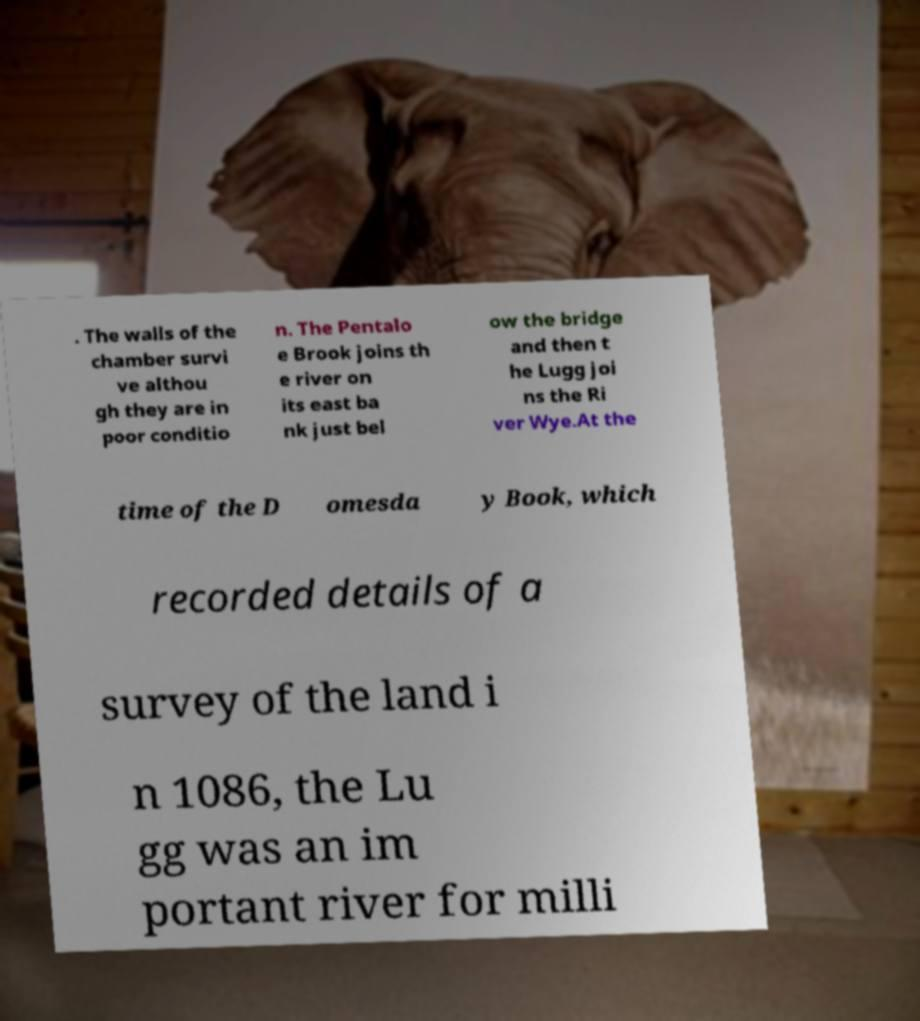Please identify and transcribe the text found in this image. . The walls of the chamber survi ve althou gh they are in poor conditio n. The Pentalo e Brook joins th e river on its east ba nk just bel ow the bridge and then t he Lugg joi ns the Ri ver Wye.At the time of the D omesda y Book, which recorded details of a survey of the land i n 1086, the Lu gg was an im portant river for milli 